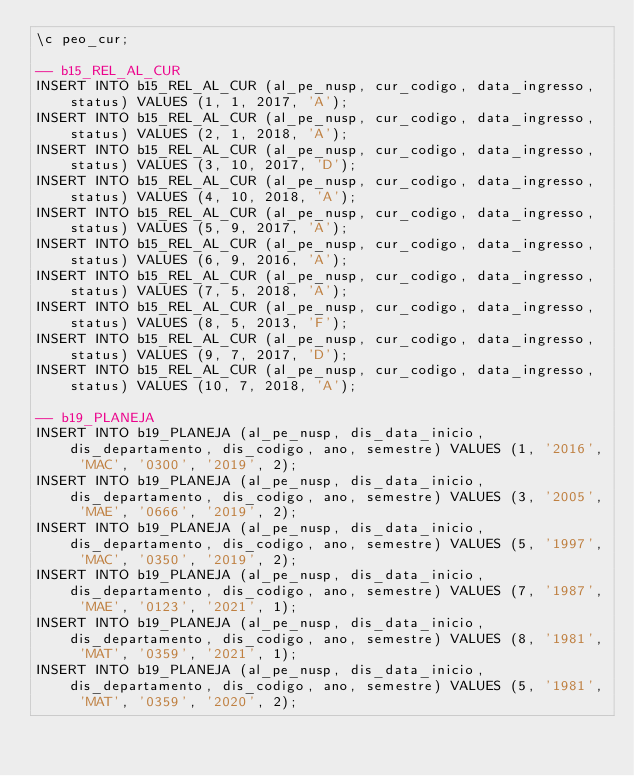Convert code to text. <code><loc_0><loc_0><loc_500><loc_500><_SQL_>\c peo_cur;

-- b15_REL_AL_CUR
INSERT INTO b15_REL_AL_CUR (al_pe_nusp, cur_codigo, data_ingresso, status) VALUES (1, 1, 2017, 'A');
INSERT INTO b15_REL_AL_CUR (al_pe_nusp, cur_codigo, data_ingresso, status) VALUES (2, 1, 2018, 'A');
INSERT INTO b15_REL_AL_CUR (al_pe_nusp, cur_codigo, data_ingresso, status) VALUES (3, 10, 2017, 'D');
INSERT INTO b15_REL_AL_CUR (al_pe_nusp, cur_codigo, data_ingresso, status) VALUES (4, 10, 2018, 'A');
INSERT INTO b15_REL_AL_CUR (al_pe_nusp, cur_codigo, data_ingresso, status) VALUES (5, 9, 2017, 'A');
INSERT INTO b15_REL_AL_CUR (al_pe_nusp, cur_codigo, data_ingresso, status) VALUES (6, 9, 2016, 'A');
INSERT INTO b15_REL_AL_CUR (al_pe_nusp, cur_codigo, data_ingresso, status) VALUES (7, 5, 2018, 'A');
INSERT INTO b15_REL_AL_CUR (al_pe_nusp, cur_codigo, data_ingresso, status) VALUES (8, 5, 2013, 'F');
INSERT INTO b15_REL_AL_CUR (al_pe_nusp, cur_codigo, data_ingresso, status) VALUES (9, 7, 2017, 'D');
INSERT INTO b15_REL_AL_CUR (al_pe_nusp, cur_codigo, data_ingresso, status) VALUES (10, 7, 2018, 'A');

-- b19_PLANEJA
INSERT INTO b19_PLANEJA (al_pe_nusp, dis_data_inicio, dis_departamento, dis_codigo, ano, semestre) VALUES (1, '2016', 'MAC', '0300', '2019', 2);
INSERT INTO b19_PLANEJA (al_pe_nusp, dis_data_inicio, dis_departamento, dis_codigo, ano, semestre) VALUES (3, '2005', 'MAE', '0666', '2019', 2);
INSERT INTO b19_PLANEJA (al_pe_nusp, dis_data_inicio, dis_departamento, dis_codigo, ano, semestre) VALUES (5, '1997', 'MAC', '0350', '2019', 2);
INSERT INTO b19_PLANEJA (al_pe_nusp, dis_data_inicio, dis_departamento, dis_codigo, ano, semestre) VALUES (7, '1987', 'MAE', '0123', '2021', 1);
INSERT INTO b19_PLANEJA (al_pe_nusp, dis_data_inicio, dis_departamento, dis_codigo, ano, semestre) VALUES (8, '1981', 'MAT', '0359', '2021', 1);
INSERT INTO b19_PLANEJA (al_pe_nusp, dis_data_inicio, dis_departamento, dis_codigo, ano, semestre) VALUES (5, '1981', 'MAT', '0359', '2020', 2);</code> 